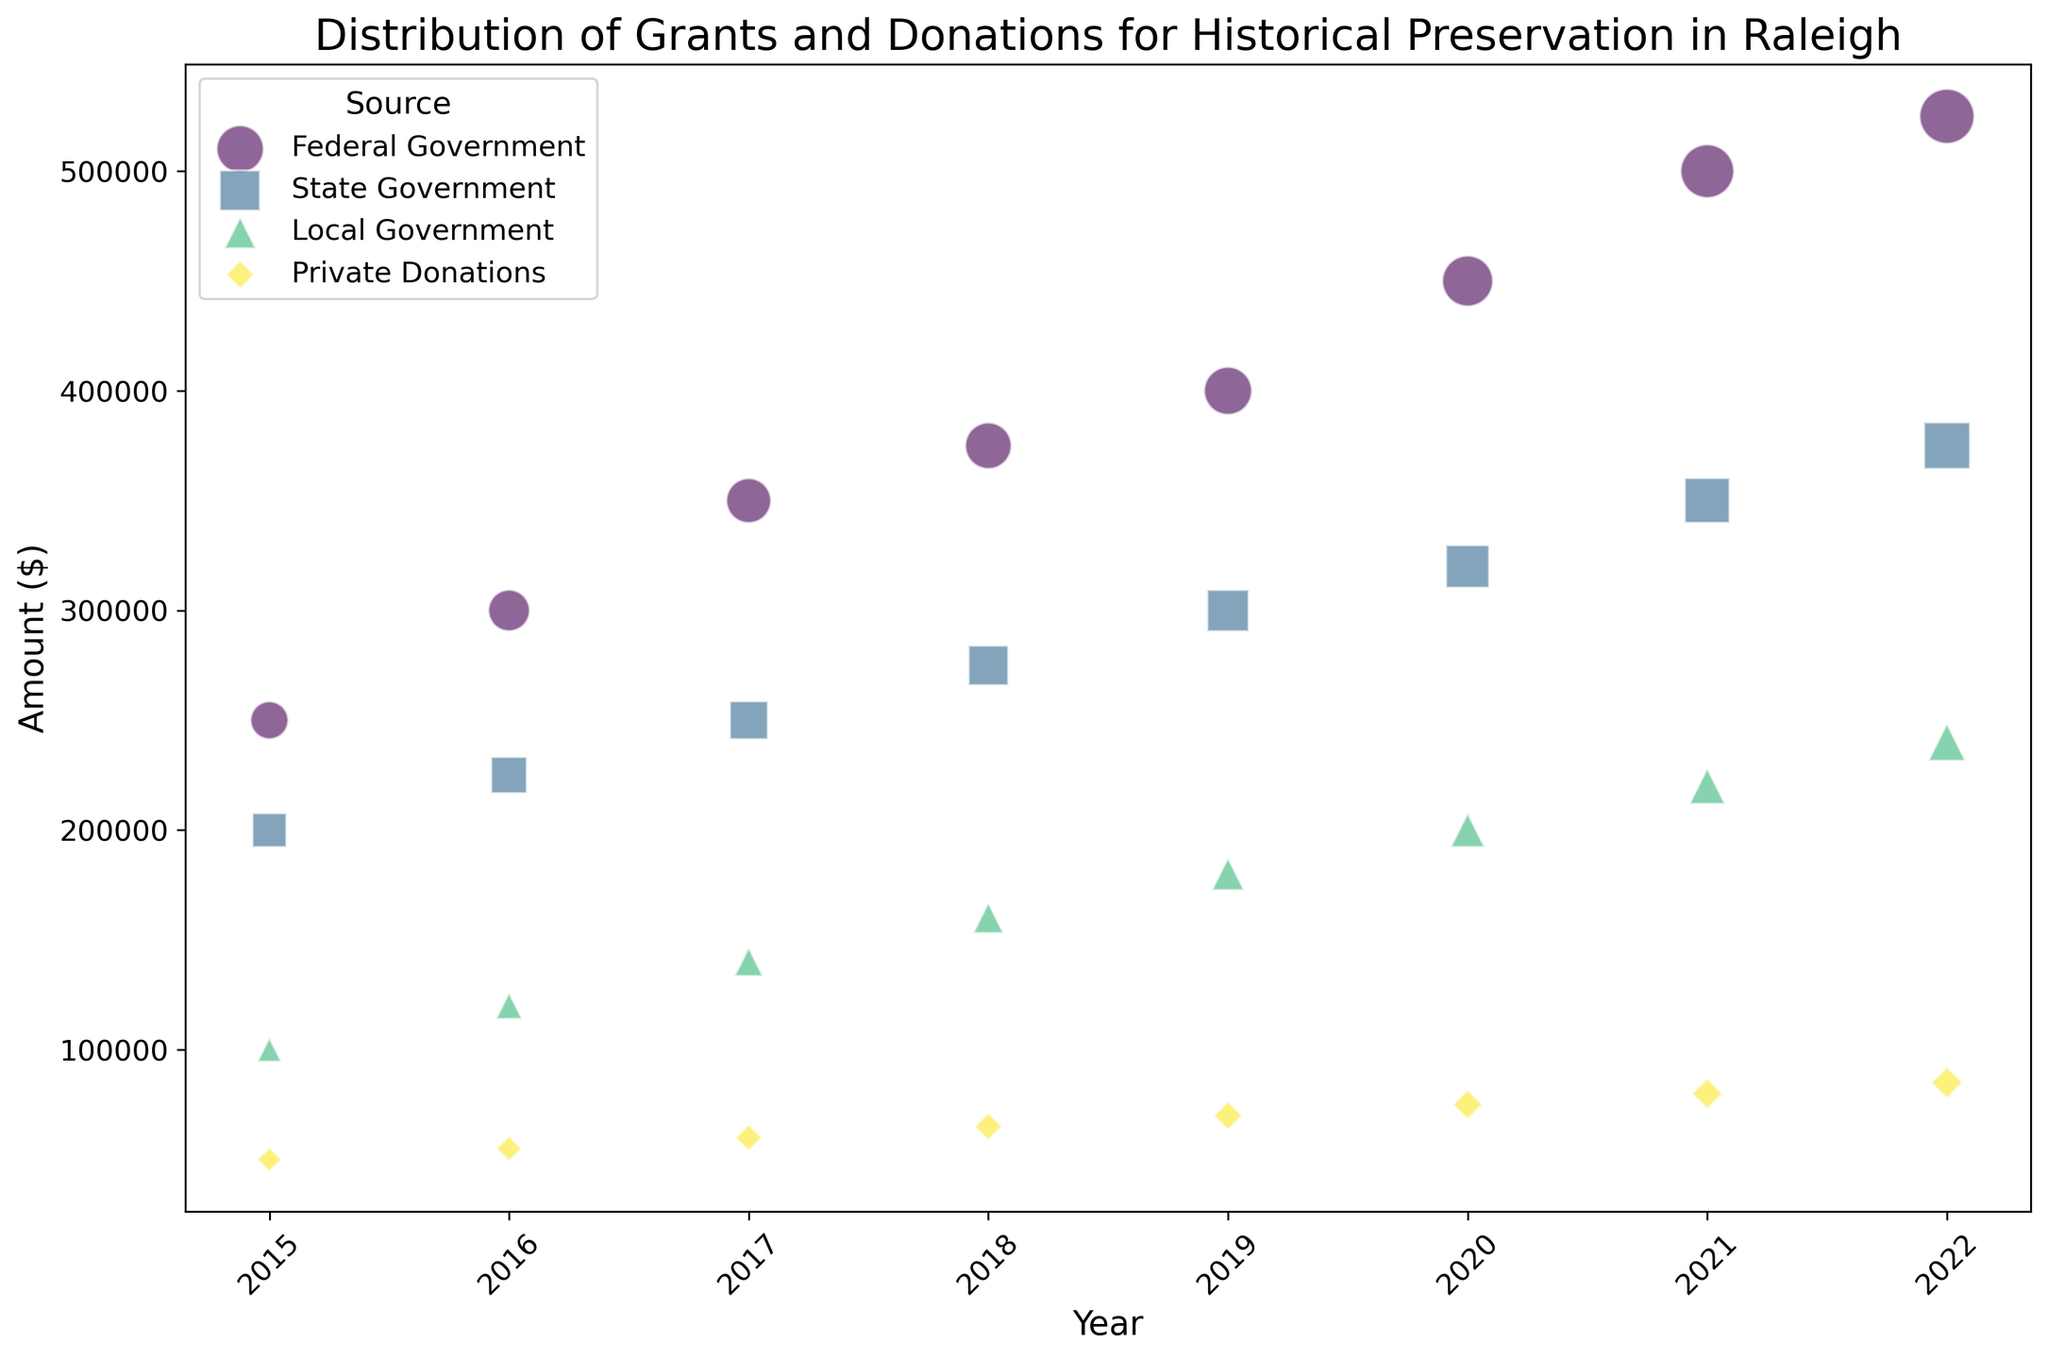What is the total amount of grants and donations received from all sources in 2022? Add the amounts for each source in 2022: Federal Government ($525,000) + State Government ($375,000) + Local Government ($240,000) + Private Donations ($85,000). The total is $525,000 + $375,000 + $240,000 + $85,000 = $1,225,000.
Answer: $1,225,000 Which source contributed the most in 2020, and what was the amount? Compare the amounts for all sources in 2020: Federal Government ($450,000), State Government ($320,000), Local Government ($200,000), Private Donations ($75,000). The Federal Government contributed the most with $450,000.
Answer: Federal Government with $450,000 How has the amount from State Government changed from 2015 to 2022? Compare the amount in 2015 ($200,000) to the amount in 2022 ($375,000). The change is $375,000 - $200,000 = $175,000 increase.
Answer: Increased by $175,000 Between 2015 and 2022, which year saw the largest increase in Federal Government funding compared to the previous year? Calculate the yearly differences for Federal Government funding: 2016-2015 ($50,000), 2017-2016 ($50,000), 2018-2017 ($25,000), 2019-2018 ($25,000), 2020-2019 ($50,000), 2021-2020 ($50,000), 2022-2021 ($25,000). The largest increase is in 2017-2016, 2020-2019, and 2021-2020 with $50,000.
Answer: 2016-2017 with $50,000 What is the overall trend in private donations from 2015 to 2022? Analyze the values from 2015 to 2022: 2015 ($50,000), 2016 ($55,000), 2017 ($60,000), 2018 ($65,000), 2019 ($70,000), 2020 ($75,000), 2021 ($80,000), 2022 ($85,000). There is an upward trend in private donations, increasing consistently each year.
Answer: Upward trend In which year did Local Government funding first reach $200,000? Look at the amounts year by year for Local Government: 2015 ($100,000), 2016 ($120,000), 2017 ($140,000), 2018 ($160,000), 2019 ($180,000), 2020 ($200,000). It first reached $200,000 in 2020.
Answer: 2020 What is the average annual amount of grants and donations from the Federal Government over the period 2015-2022? Calculate the sum of Federal Government amounts from 2015 to 2022: $250,000 + $300,000 + $350,000 + $375,000 + $400,000 + $450,000 + $500,000 + $525,000 = $3,150,000. The average is $3,150,000 / 8 years = $393,750.
Answer: $393,750 Which source has shown the steadier increase over the years, Federal Government or Private Donations? Observe the amounts and consistency of annual increases: Federal Government has steady increases with occasional equal increments, while Private Donations show equal annual increases ($5,000). Overall, Private Donations have shown a steadier, more consistent increase.
Answer: Private Donations 